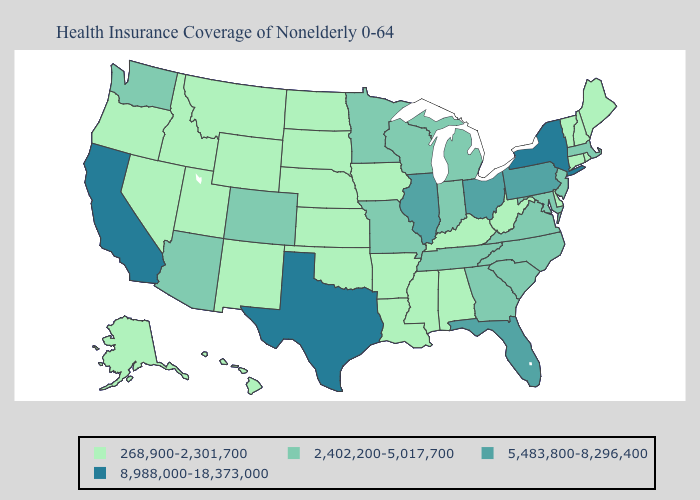Does the map have missing data?
Answer briefly. No. What is the lowest value in states that border Florida?
Answer briefly. 268,900-2,301,700. Name the states that have a value in the range 268,900-2,301,700?
Give a very brief answer. Alabama, Alaska, Arkansas, Connecticut, Delaware, Hawaii, Idaho, Iowa, Kansas, Kentucky, Louisiana, Maine, Mississippi, Montana, Nebraska, Nevada, New Hampshire, New Mexico, North Dakota, Oklahoma, Oregon, Rhode Island, South Dakota, Utah, Vermont, West Virginia, Wyoming. What is the lowest value in states that border Idaho?
Write a very short answer. 268,900-2,301,700. Among the states that border Indiana , which have the highest value?
Keep it brief. Illinois, Ohio. Name the states that have a value in the range 8,988,000-18,373,000?
Short answer required. California, New York, Texas. Name the states that have a value in the range 5,483,800-8,296,400?
Give a very brief answer. Florida, Illinois, Ohio, Pennsylvania. What is the highest value in the Northeast ?
Answer briefly. 8,988,000-18,373,000. Name the states that have a value in the range 268,900-2,301,700?
Be succinct. Alabama, Alaska, Arkansas, Connecticut, Delaware, Hawaii, Idaho, Iowa, Kansas, Kentucky, Louisiana, Maine, Mississippi, Montana, Nebraska, Nevada, New Hampshire, New Mexico, North Dakota, Oklahoma, Oregon, Rhode Island, South Dakota, Utah, Vermont, West Virginia, Wyoming. How many symbols are there in the legend?
Be succinct. 4. Which states hav the highest value in the MidWest?
Concise answer only. Illinois, Ohio. Among the states that border New York , does Connecticut have the highest value?
Short answer required. No. What is the lowest value in the USA?
Give a very brief answer. 268,900-2,301,700. Name the states that have a value in the range 8,988,000-18,373,000?
Answer briefly. California, New York, Texas. Does Minnesota have a lower value than Florida?
Answer briefly. Yes. 